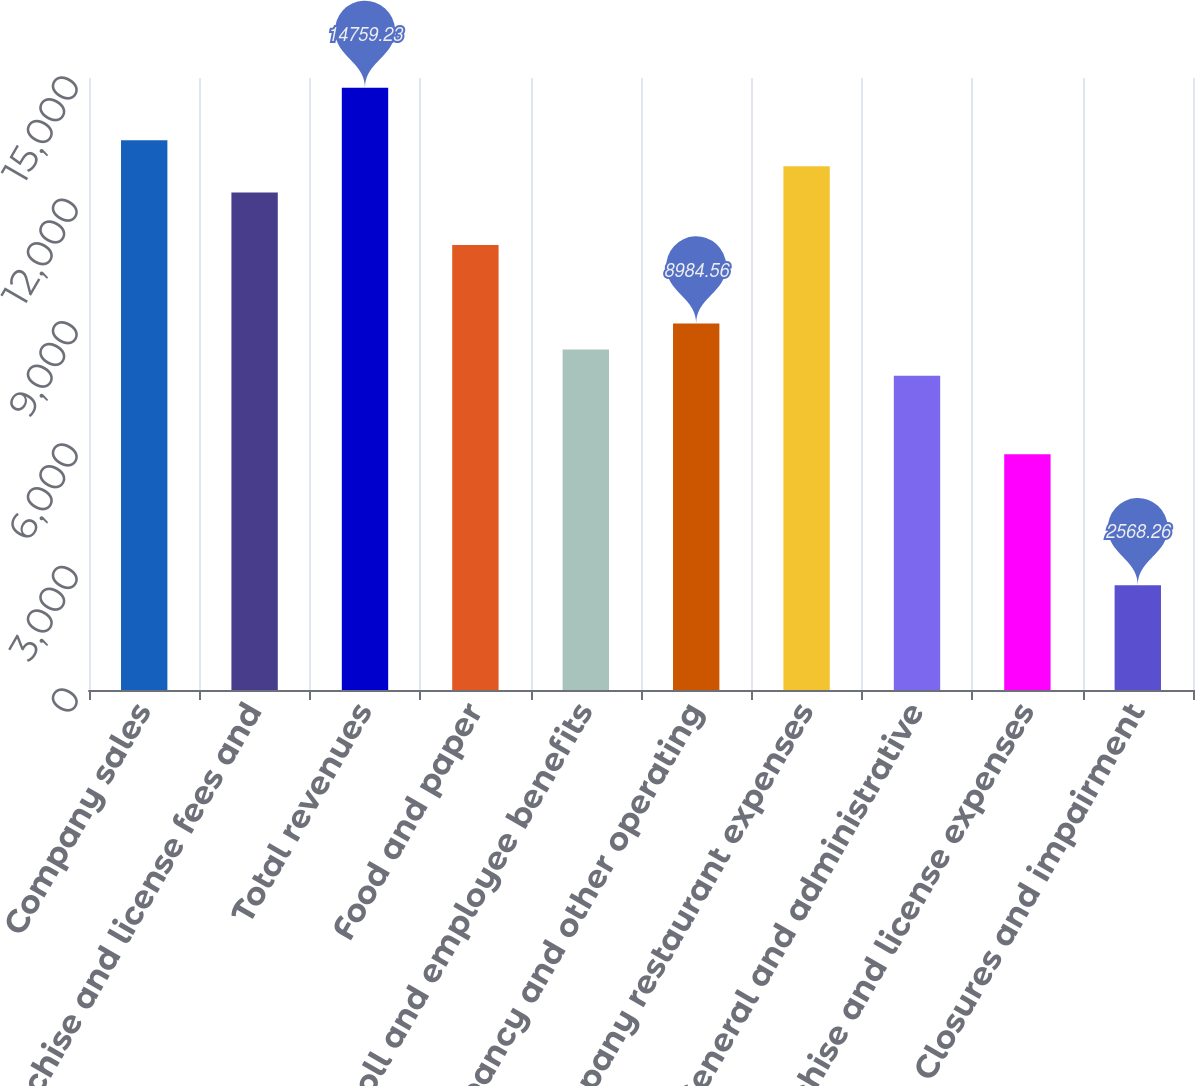<chart> <loc_0><loc_0><loc_500><loc_500><bar_chart><fcel>Company sales<fcel>Franchise and license fees and<fcel>Total revenues<fcel>Food and paper<fcel>Payroll and employee benefits<fcel>Occupancy and other operating<fcel>Company restaurant expenses<fcel>General and administrative<fcel>Franchise and license expenses<fcel>Closures and impairment<nl><fcel>13476<fcel>12192.7<fcel>14759.2<fcel>10909.5<fcel>8342.93<fcel>8984.56<fcel>12834.3<fcel>7701.3<fcel>5776.41<fcel>2568.26<nl></chart> 